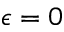<formula> <loc_0><loc_0><loc_500><loc_500>\epsilon = 0</formula> 